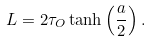<formula> <loc_0><loc_0><loc_500><loc_500>L = 2 \tau _ { O } \tanh \left ( \frac { a } { 2 } \right ) .</formula> 